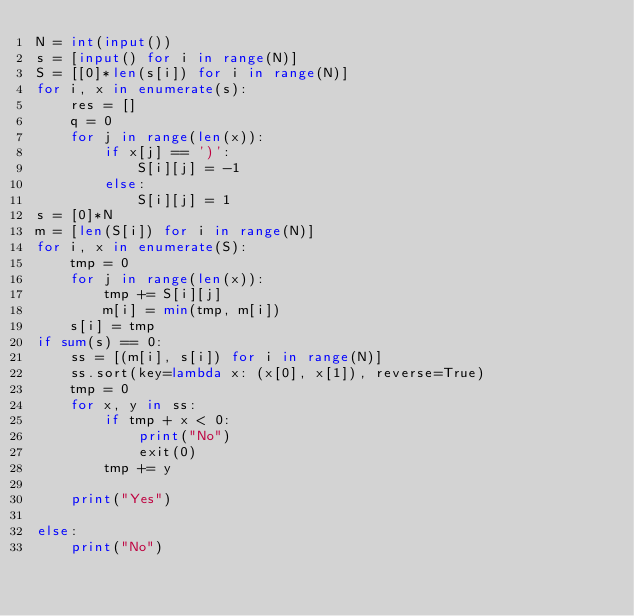Convert code to text. <code><loc_0><loc_0><loc_500><loc_500><_Python_>N = int(input())
s = [input() for i in range(N)]
S = [[0]*len(s[i]) for i in range(N)]
for i, x in enumerate(s):
    res = []
    q = 0
    for j in range(len(x)):
        if x[j] == ')':
            S[i][j] = -1
        else:
            S[i][j] = 1
s = [0]*N
m = [len(S[i]) for i in range(N)]
for i, x in enumerate(S):
    tmp = 0
    for j in range(len(x)):
        tmp += S[i][j]
        m[i] = min(tmp, m[i])
    s[i] = tmp
if sum(s) == 0:
    ss = [(m[i], s[i]) for i in range(N)]
    ss.sort(key=lambda x: (x[0], x[1]), reverse=True)
    tmp = 0
    for x, y in ss:
        if tmp + x < 0:
            print("No")
            exit(0)
        tmp += y

    print("Yes")

else:
    print("No")
</code> 